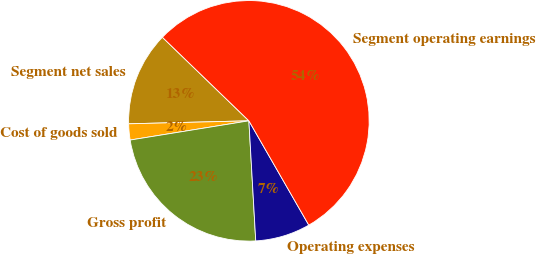Convert chart to OTSL. <chart><loc_0><loc_0><loc_500><loc_500><pie_chart><fcel>Segment net sales<fcel>Cost of goods sold<fcel>Gross profit<fcel>Operating expenses<fcel>Segment operating earnings<nl><fcel>12.62%<fcel>2.16%<fcel>23.35%<fcel>7.39%<fcel>54.47%<nl></chart> 